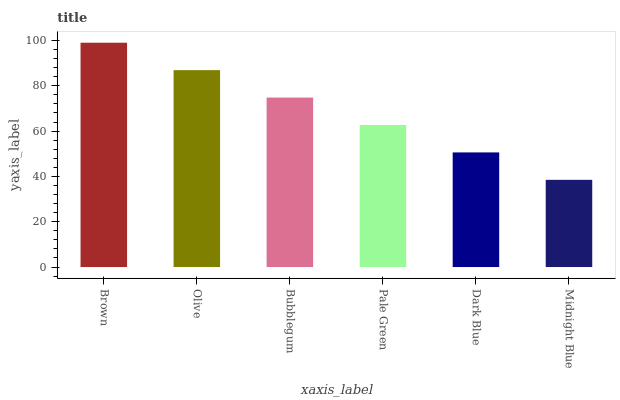Is Olive the minimum?
Answer yes or no. No. Is Olive the maximum?
Answer yes or no. No. Is Brown greater than Olive?
Answer yes or no. Yes. Is Olive less than Brown?
Answer yes or no. Yes. Is Olive greater than Brown?
Answer yes or no. No. Is Brown less than Olive?
Answer yes or no. No. Is Bubblegum the high median?
Answer yes or no. Yes. Is Pale Green the low median?
Answer yes or no. Yes. Is Dark Blue the high median?
Answer yes or no. No. Is Midnight Blue the low median?
Answer yes or no. No. 